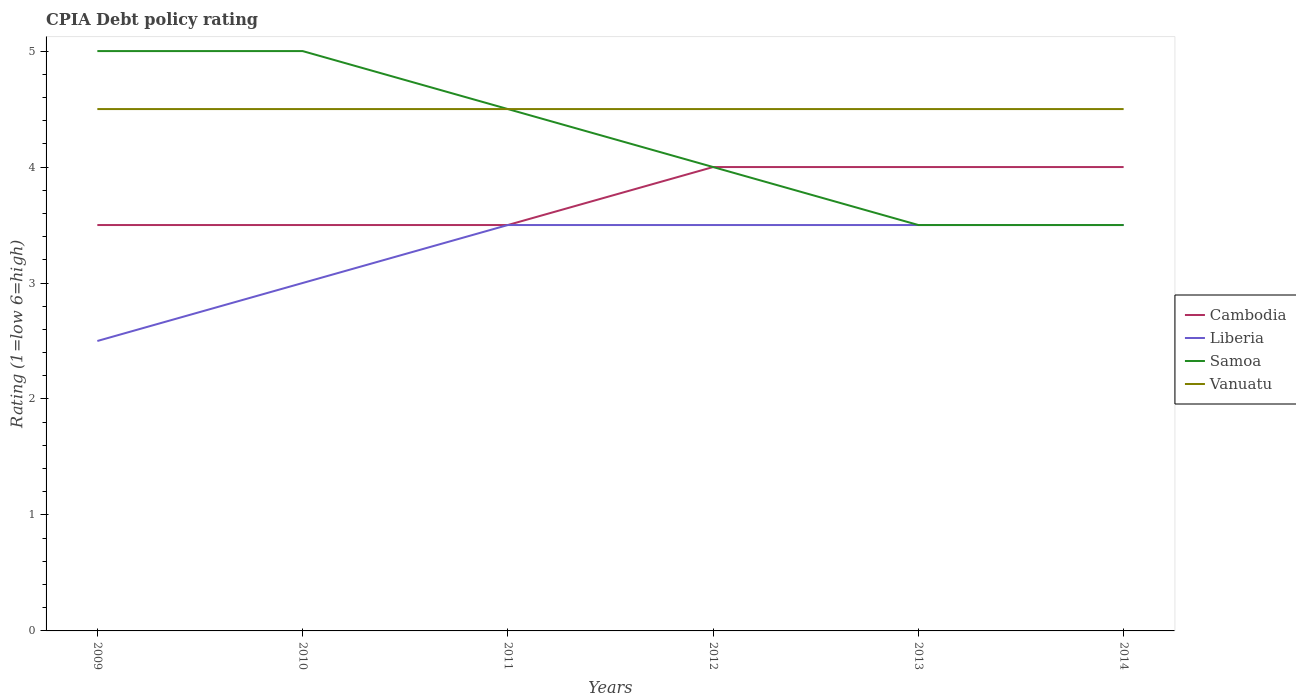Does the line corresponding to Cambodia intersect with the line corresponding to Liberia?
Your answer should be very brief. Yes. Is the CPIA rating in Samoa strictly greater than the CPIA rating in Vanuatu over the years?
Ensure brevity in your answer.  No. How many lines are there?
Provide a short and direct response. 4. Are the values on the major ticks of Y-axis written in scientific E-notation?
Make the answer very short. No. Does the graph contain any zero values?
Keep it short and to the point. No. Where does the legend appear in the graph?
Provide a short and direct response. Center right. How many legend labels are there?
Keep it short and to the point. 4. What is the title of the graph?
Your answer should be very brief. CPIA Debt policy rating. Does "Belarus" appear as one of the legend labels in the graph?
Your response must be concise. No. What is the label or title of the Y-axis?
Your answer should be compact. Rating (1=low 6=high). What is the Rating (1=low 6=high) of Cambodia in 2009?
Give a very brief answer. 3.5. What is the Rating (1=low 6=high) of Liberia in 2009?
Your response must be concise. 2.5. What is the Rating (1=low 6=high) of Liberia in 2012?
Your response must be concise. 3.5. What is the Rating (1=low 6=high) of Samoa in 2012?
Provide a succinct answer. 4. What is the Rating (1=low 6=high) in Liberia in 2013?
Keep it short and to the point. 3.5. What is the Rating (1=low 6=high) in Cambodia in 2014?
Your response must be concise. 4. Across all years, what is the maximum Rating (1=low 6=high) of Cambodia?
Provide a short and direct response. 4. Across all years, what is the maximum Rating (1=low 6=high) in Liberia?
Your response must be concise. 3.5. Across all years, what is the maximum Rating (1=low 6=high) of Vanuatu?
Your answer should be compact. 4.5. Across all years, what is the minimum Rating (1=low 6=high) in Liberia?
Your response must be concise. 2.5. What is the total Rating (1=low 6=high) in Cambodia in the graph?
Your answer should be compact. 22.5. What is the total Rating (1=low 6=high) in Liberia in the graph?
Make the answer very short. 19.5. What is the total Rating (1=low 6=high) of Samoa in the graph?
Provide a succinct answer. 25.5. What is the difference between the Rating (1=low 6=high) in Liberia in 2009 and that in 2010?
Give a very brief answer. -0.5. What is the difference between the Rating (1=low 6=high) in Vanuatu in 2009 and that in 2010?
Keep it short and to the point. 0. What is the difference between the Rating (1=low 6=high) of Cambodia in 2009 and that in 2011?
Keep it short and to the point. 0. What is the difference between the Rating (1=low 6=high) in Liberia in 2009 and that in 2011?
Offer a very short reply. -1. What is the difference between the Rating (1=low 6=high) of Samoa in 2009 and that in 2011?
Provide a succinct answer. 0.5. What is the difference between the Rating (1=low 6=high) of Vanuatu in 2009 and that in 2011?
Provide a succinct answer. 0. What is the difference between the Rating (1=low 6=high) of Cambodia in 2009 and that in 2013?
Your answer should be compact. -0.5. What is the difference between the Rating (1=low 6=high) of Samoa in 2009 and that in 2013?
Give a very brief answer. 1.5. What is the difference between the Rating (1=low 6=high) in Vanuatu in 2009 and that in 2013?
Ensure brevity in your answer.  0. What is the difference between the Rating (1=low 6=high) of Vanuatu in 2009 and that in 2014?
Offer a terse response. 0. What is the difference between the Rating (1=low 6=high) in Cambodia in 2010 and that in 2011?
Your response must be concise. 0. What is the difference between the Rating (1=low 6=high) of Samoa in 2010 and that in 2011?
Make the answer very short. 0.5. What is the difference between the Rating (1=low 6=high) in Vanuatu in 2010 and that in 2011?
Offer a terse response. 0. What is the difference between the Rating (1=low 6=high) in Samoa in 2010 and that in 2012?
Provide a short and direct response. 1. What is the difference between the Rating (1=low 6=high) in Vanuatu in 2010 and that in 2012?
Your answer should be very brief. 0. What is the difference between the Rating (1=low 6=high) of Liberia in 2010 and that in 2013?
Provide a succinct answer. -0.5. What is the difference between the Rating (1=low 6=high) in Samoa in 2010 and that in 2013?
Provide a succinct answer. 1.5. What is the difference between the Rating (1=low 6=high) in Vanuatu in 2010 and that in 2013?
Your answer should be compact. 0. What is the difference between the Rating (1=low 6=high) in Cambodia in 2010 and that in 2014?
Give a very brief answer. -0.5. What is the difference between the Rating (1=low 6=high) in Liberia in 2010 and that in 2014?
Give a very brief answer. -0.5. What is the difference between the Rating (1=low 6=high) of Samoa in 2010 and that in 2014?
Your answer should be compact. 1.5. What is the difference between the Rating (1=low 6=high) in Vanuatu in 2010 and that in 2014?
Keep it short and to the point. 0. What is the difference between the Rating (1=low 6=high) of Samoa in 2011 and that in 2012?
Offer a very short reply. 0.5. What is the difference between the Rating (1=low 6=high) of Liberia in 2011 and that in 2013?
Your answer should be compact. 0. What is the difference between the Rating (1=low 6=high) of Cambodia in 2012 and that in 2013?
Keep it short and to the point. 0. What is the difference between the Rating (1=low 6=high) in Samoa in 2012 and that in 2013?
Offer a terse response. 0.5. What is the difference between the Rating (1=low 6=high) of Liberia in 2012 and that in 2014?
Give a very brief answer. 0. What is the difference between the Rating (1=low 6=high) of Samoa in 2012 and that in 2014?
Your answer should be compact. 0.5. What is the difference between the Rating (1=low 6=high) in Vanuatu in 2012 and that in 2014?
Offer a very short reply. 0. What is the difference between the Rating (1=low 6=high) in Cambodia in 2013 and that in 2014?
Your answer should be compact. 0. What is the difference between the Rating (1=low 6=high) of Liberia in 2013 and that in 2014?
Keep it short and to the point. 0. What is the difference between the Rating (1=low 6=high) in Samoa in 2013 and that in 2014?
Your response must be concise. 0. What is the difference between the Rating (1=low 6=high) of Cambodia in 2009 and the Rating (1=low 6=high) of Vanuatu in 2010?
Offer a very short reply. -1. What is the difference between the Rating (1=low 6=high) in Samoa in 2009 and the Rating (1=low 6=high) in Vanuatu in 2010?
Offer a terse response. 0.5. What is the difference between the Rating (1=low 6=high) in Cambodia in 2009 and the Rating (1=low 6=high) in Liberia in 2011?
Make the answer very short. 0. What is the difference between the Rating (1=low 6=high) in Cambodia in 2009 and the Rating (1=low 6=high) in Samoa in 2011?
Your answer should be compact. -1. What is the difference between the Rating (1=low 6=high) in Samoa in 2009 and the Rating (1=low 6=high) in Vanuatu in 2011?
Provide a short and direct response. 0.5. What is the difference between the Rating (1=low 6=high) of Liberia in 2009 and the Rating (1=low 6=high) of Samoa in 2012?
Ensure brevity in your answer.  -1.5. What is the difference between the Rating (1=low 6=high) of Cambodia in 2009 and the Rating (1=low 6=high) of Liberia in 2013?
Offer a terse response. 0. What is the difference between the Rating (1=low 6=high) in Cambodia in 2009 and the Rating (1=low 6=high) in Samoa in 2013?
Provide a short and direct response. 0. What is the difference between the Rating (1=low 6=high) in Cambodia in 2009 and the Rating (1=low 6=high) in Vanuatu in 2013?
Give a very brief answer. -1. What is the difference between the Rating (1=low 6=high) in Samoa in 2009 and the Rating (1=low 6=high) in Vanuatu in 2013?
Offer a terse response. 0.5. What is the difference between the Rating (1=low 6=high) of Cambodia in 2009 and the Rating (1=low 6=high) of Liberia in 2014?
Provide a succinct answer. 0. What is the difference between the Rating (1=low 6=high) in Liberia in 2009 and the Rating (1=low 6=high) in Samoa in 2014?
Ensure brevity in your answer.  -1. What is the difference between the Rating (1=low 6=high) in Liberia in 2009 and the Rating (1=low 6=high) in Vanuatu in 2014?
Your response must be concise. -2. What is the difference between the Rating (1=low 6=high) in Samoa in 2009 and the Rating (1=low 6=high) in Vanuatu in 2014?
Offer a very short reply. 0.5. What is the difference between the Rating (1=low 6=high) in Cambodia in 2010 and the Rating (1=low 6=high) in Samoa in 2011?
Your answer should be compact. -1. What is the difference between the Rating (1=low 6=high) of Liberia in 2010 and the Rating (1=low 6=high) of Samoa in 2011?
Offer a terse response. -1.5. What is the difference between the Rating (1=low 6=high) of Samoa in 2010 and the Rating (1=low 6=high) of Vanuatu in 2011?
Offer a terse response. 0.5. What is the difference between the Rating (1=low 6=high) in Cambodia in 2010 and the Rating (1=low 6=high) in Liberia in 2012?
Give a very brief answer. 0. What is the difference between the Rating (1=low 6=high) of Cambodia in 2010 and the Rating (1=low 6=high) of Vanuatu in 2012?
Provide a succinct answer. -1. What is the difference between the Rating (1=low 6=high) of Liberia in 2010 and the Rating (1=low 6=high) of Samoa in 2012?
Give a very brief answer. -1. What is the difference between the Rating (1=low 6=high) in Liberia in 2010 and the Rating (1=low 6=high) in Vanuatu in 2012?
Offer a terse response. -1.5. What is the difference between the Rating (1=low 6=high) of Samoa in 2010 and the Rating (1=low 6=high) of Vanuatu in 2012?
Keep it short and to the point. 0.5. What is the difference between the Rating (1=low 6=high) of Cambodia in 2010 and the Rating (1=low 6=high) of Liberia in 2013?
Your answer should be compact. 0. What is the difference between the Rating (1=low 6=high) in Cambodia in 2010 and the Rating (1=low 6=high) in Samoa in 2013?
Make the answer very short. 0. What is the difference between the Rating (1=low 6=high) in Liberia in 2010 and the Rating (1=low 6=high) in Samoa in 2013?
Offer a very short reply. -0.5. What is the difference between the Rating (1=low 6=high) in Liberia in 2010 and the Rating (1=low 6=high) in Vanuatu in 2013?
Keep it short and to the point. -1.5. What is the difference between the Rating (1=low 6=high) in Samoa in 2010 and the Rating (1=low 6=high) in Vanuatu in 2013?
Give a very brief answer. 0.5. What is the difference between the Rating (1=low 6=high) of Cambodia in 2010 and the Rating (1=low 6=high) of Samoa in 2014?
Offer a very short reply. 0. What is the difference between the Rating (1=low 6=high) of Liberia in 2010 and the Rating (1=low 6=high) of Vanuatu in 2014?
Give a very brief answer. -1.5. What is the difference between the Rating (1=low 6=high) of Samoa in 2010 and the Rating (1=low 6=high) of Vanuatu in 2014?
Your answer should be compact. 0.5. What is the difference between the Rating (1=low 6=high) in Cambodia in 2011 and the Rating (1=low 6=high) in Samoa in 2012?
Provide a short and direct response. -0.5. What is the difference between the Rating (1=low 6=high) of Cambodia in 2011 and the Rating (1=low 6=high) of Vanuatu in 2012?
Give a very brief answer. -1. What is the difference between the Rating (1=low 6=high) in Liberia in 2011 and the Rating (1=low 6=high) in Samoa in 2012?
Make the answer very short. -0.5. What is the difference between the Rating (1=low 6=high) in Samoa in 2011 and the Rating (1=low 6=high) in Vanuatu in 2012?
Your answer should be compact. 0. What is the difference between the Rating (1=low 6=high) of Cambodia in 2011 and the Rating (1=low 6=high) of Vanuatu in 2013?
Provide a succinct answer. -1. What is the difference between the Rating (1=low 6=high) in Liberia in 2011 and the Rating (1=low 6=high) in Vanuatu in 2013?
Ensure brevity in your answer.  -1. What is the difference between the Rating (1=low 6=high) in Cambodia in 2011 and the Rating (1=low 6=high) in Samoa in 2014?
Give a very brief answer. 0. What is the difference between the Rating (1=low 6=high) in Cambodia in 2011 and the Rating (1=low 6=high) in Vanuatu in 2014?
Make the answer very short. -1. What is the difference between the Rating (1=low 6=high) in Cambodia in 2012 and the Rating (1=low 6=high) in Liberia in 2013?
Make the answer very short. 0.5. What is the difference between the Rating (1=low 6=high) in Liberia in 2012 and the Rating (1=low 6=high) in Samoa in 2013?
Ensure brevity in your answer.  0. What is the difference between the Rating (1=low 6=high) of Cambodia in 2012 and the Rating (1=low 6=high) of Samoa in 2014?
Your answer should be very brief. 0.5. What is the difference between the Rating (1=low 6=high) in Cambodia in 2012 and the Rating (1=low 6=high) in Vanuatu in 2014?
Your answer should be very brief. -0.5. What is the difference between the Rating (1=low 6=high) in Liberia in 2012 and the Rating (1=low 6=high) in Samoa in 2014?
Offer a terse response. 0. What is the difference between the Rating (1=low 6=high) in Cambodia in 2013 and the Rating (1=low 6=high) in Samoa in 2014?
Provide a succinct answer. 0.5. What is the average Rating (1=low 6=high) of Cambodia per year?
Give a very brief answer. 3.75. What is the average Rating (1=low 6=high) of Liberia per year?
Give a very brief answer. 3.25. What is the average Rating (1=low 6=high) of Samoa per year?
Give a very brief answer. 4.25. In the year 2009, what is the difference between the Rating (1=low 6=high) in Cambodia and Rating (1=low 6=high) in Liberia?
Give a very brief answer. 1. In the year 2009, what is the difference between the Rating (1=low 6=high) of Cambodia and Rating (1=low 6=high) of Samoa?
Offer a terse response. -1.5. In the year 2009, what is the difference between the Rating (1=low 6=high) of Liberia and Rating (1=low 6=high) of Samoa?
Ensure brevity in your answer.  -2.5. In the year 2009, what is the difference between the Rating (1=low 6=high) of Liberia and Rating (1=low 6=high) of Vanuatu?
Offer a very short reply. -2. In the year 2010, what is the difference between the Rating (1=low 6=high) of Cambodia and Rating (1=low 6=high) of Liberia?
Provide a short and direct response. 0.5. In the year 2010, what is the difference between the Rating (1=low 6=high) in Cambodia and Rating (1=low 6=high) in Samoa?
Ensure brevity in your answer.  -1.5. In the year 2010, what is the difference between the Rating (1=low 6=high) of Cambodia and Rating (1=low 6=high) of Vanuatu?
Make the answer very short. -1. In the year 2010, what is the difference between the Rating (1=low 6=high) in Samoa and Rating (1=low 6=high) in Vanuatu?
Provide a succinct answer. 0.5. In the year 2011, what is the difference between the Rating (1=low 6=high) of Cambodia and Rating (1=low 6=high) of Liberia?
Give a very brief answer. 0. In the year 2011, what is the difference between the Rating (1=low 6=high) in Cambodia and Rating (1=low 6=high) in Samoa?
Offer a very short reply. -1. In the year 2012, what is the difference between the Rating (1=low 6=high) of Cambodia and Rating (1=low 6=high) of Samoa?
Your answer should be compact. 0. In the year 2012, what is the difference between the Rating (1=low 6=high) in Cambodia and Rating (1=low 6=high) in Vanuatu?
Offer a terse response. -0.5. In the year 2012, what is the difference between the Rating (1=low 6=high) of Liberia and Rating (1=low 6=high) of Vanuatu?
Offer a terse response. -1. In the year 2012, what is the difference between the Rating (1=low 6=high) of Samoa and Rating (1=low 6=high) of Vanuatu?
Offer a terse response. -0.5. In the year 2013, what is the difference between the Rating (1=low 6=high) in Cambodia and Rating (1=low 6=high) in Liberia?
Keep it short and to the point. 0.5. In the year 2013, what is the difference between the Rating (1=low 6=high) in Cambodia and Rating (1=low 6=high) in Samoa?
Make the answer very short. 0.5. In the year 2013, what is the difference between the Rating (1=low 6=high) of Cambodia and Rating (1=low 6=high) of Vanuatu?
Your response must be concise. -0.5. In the year 2013, what is the difference between the Rating (1=low 6=high) in Liberia and Rating (1=low 6=high) in Samoa?
Offer a very short reply. 0. In the year 2013, what is the difference between the Rating (1=low 6=high) in Liberia and Rating (1=low 6=high) in Vanuatu?
Your answer should be very brief. -1. In the year 2014, what is the difference between the Rating (1=low 6=high) in Liberia and Rating (1=low 6=high) in Samoa?
Make the answer very short. 0. In the year 2014, what is the difference between the Rating (1=low 6=high) of Liberia and Rating (1=low 6=high) of Vanuatu?
Give a very brief answer. -1. In the year 2014, what is the difference between the Rating (1=low 6=high) of Samoa and Rating (1=low 6=high) of Vanuatu?
Ensure brevity in your answer.  -1. What is the ratio of the Rating (1=low 6=high) of Vanuatu in 2009 to that in 2010?
Your response must be concise. 1. What is the ratio of the Rating (1=low 6=high) of Samoa in 2009 to that in 2011?
Your answer should be very brief. 1.11. What is the ratio of the Rating (1=low 6=high) of Liberia in 2009 to that in 2012?
Make the answer very short. 0.71. What is the ratio of the Rating (1=low 6=high) of Cambodia in 2009 to that in 2013?
Provide a short and direct response. 0.88. What is the ratio of the Rating (1=low 6=high) in Liberia in 2009 to that in 2013?
Ensure brevity in your answer.  0.71. What is the ratio of the Rating (1=low 6=high) in Samoa in 2009 to that in 2013?
Make the answer very short. 1.43. What is the ratio of the Rating (1=low 6=high) in Vanuatu in 2009 to that in 2013?
Your answer should be very brief. 1. What is the ratio of the Rating (1=low 6=high) of Liberia in 2009 to that in 2014?
Your response must be concise. 0.71. What is the ratio of the Rating (1=low 6=high) in Samoa in 2009 to that in 2014?
Provide a short and direct response. 1.43. What is the ratio of the Rating (1=low 6=high) in Cambodia in 2010 to that in 2011?
Provide a short and direct response. 1. What is the ratio of the Rating (1=low 6=high) in Samoa in 2010 to that in 2011?
Make the answer very short. 1.11. What is the ratio of the Rating (1=low 6=high) of Vanuatu in 2010 to that in 2011?
Make the answer very short. 1. What is the ratio of the Rating (1=low 6=high) in Vanuatu in 2010 to that in 2012?
Make the answer very short. 1. What is the ratio of the Rating (1=low 6=high) in Cambodia in 2010 to that in 2013?
Provide a succinct answer. 0.88. What is the ratio of the Rating (1=low 6=high) of Liberia in 2010 to that in 2013?
Ensure brevity in your answer.  0.86. What is the ratio of the Rating (1=low 6=high) in Samoa in 2010 to that in 2013?
Your response must be concise. 1.43. What is the ratio of the Rating (1=low 6=high) in Cambodia in 2010 to that in 2014?
Give a very brief answer. 0.88. What is the ratio of the Rating (1=low 6=high) in Liberia in 2010 to that in 2014?
Your response must be concise. 0.86. What is the ratio of the Rating (1=low 6=high) of Samoa in 2010 to that in 2014?
Your answer should be compact. 1.43. What is the ratio of the Rating (1=low 6=high) of Cambodia in 2011 to that in 2013?
Provide a short and direct response. 0.88. What is the ratio of the Rating (1=low 6=high) of Samoa in 2011 to that in 2013?
Make the answer very short. 1.29. What is the ratio of the Rating (1=low 6=high) in Vanuatu in 2011 to that in 2013?
Your answer should be very brief. 1. What is the ratio of the Rating (1=low 6=high) in Liberia in 2011 to that in 2014?
Your answer should be compact. 1. What is the ratio of the Rating (1=low 6=high) in Samoa in 2011 to that in 2014?
Make the answer very short. 1.29. What is the ratio of the Rating (1=low 6=high) of Cambodia in 2012 to that in 2013?
Ensure brevity in your answer.  1. What is the ratio of the Rating (1=low 6=high) in Liberia in 2012 to that in 2013?
Ensure brevity in your answer.  1. What is the ratio of the Rating (1=low 6=high) in Samoa in 2012 to that in 2013?
Give a very brief answer. 1.14. What is the ratio of the Rating (1=low 6=high) of Liberia in 2012 to that in 2014?
Give a very brief answer. 1. What is the ratio of the Rating (1=low 6=high) of Vanuatu in 2012 to that in 2014?
Give a very brief answer. 1. What is the ratio of the Rating (1=low 6=high) in Cambodia in 2013 to that in 2014?
Keep it short and to the point. 1. What is the ratio of the Rating (1=low 6=high) of Samoa in 2013 to that in 2014?
Offer a terse response. 1. What is the difference between the highest and the second highest Rating (1=low 6=high) of Liberia?
Provide a succinct answer. 0. What is the difference between the highest and the second highest Rating (1=low 6=high) in Vanuatu?
Provide a succinct answer. 0. What is the difference between the highest and the lowest Rating (1=low 6=high) of Liberia?
Give a very brief answer. 1. 